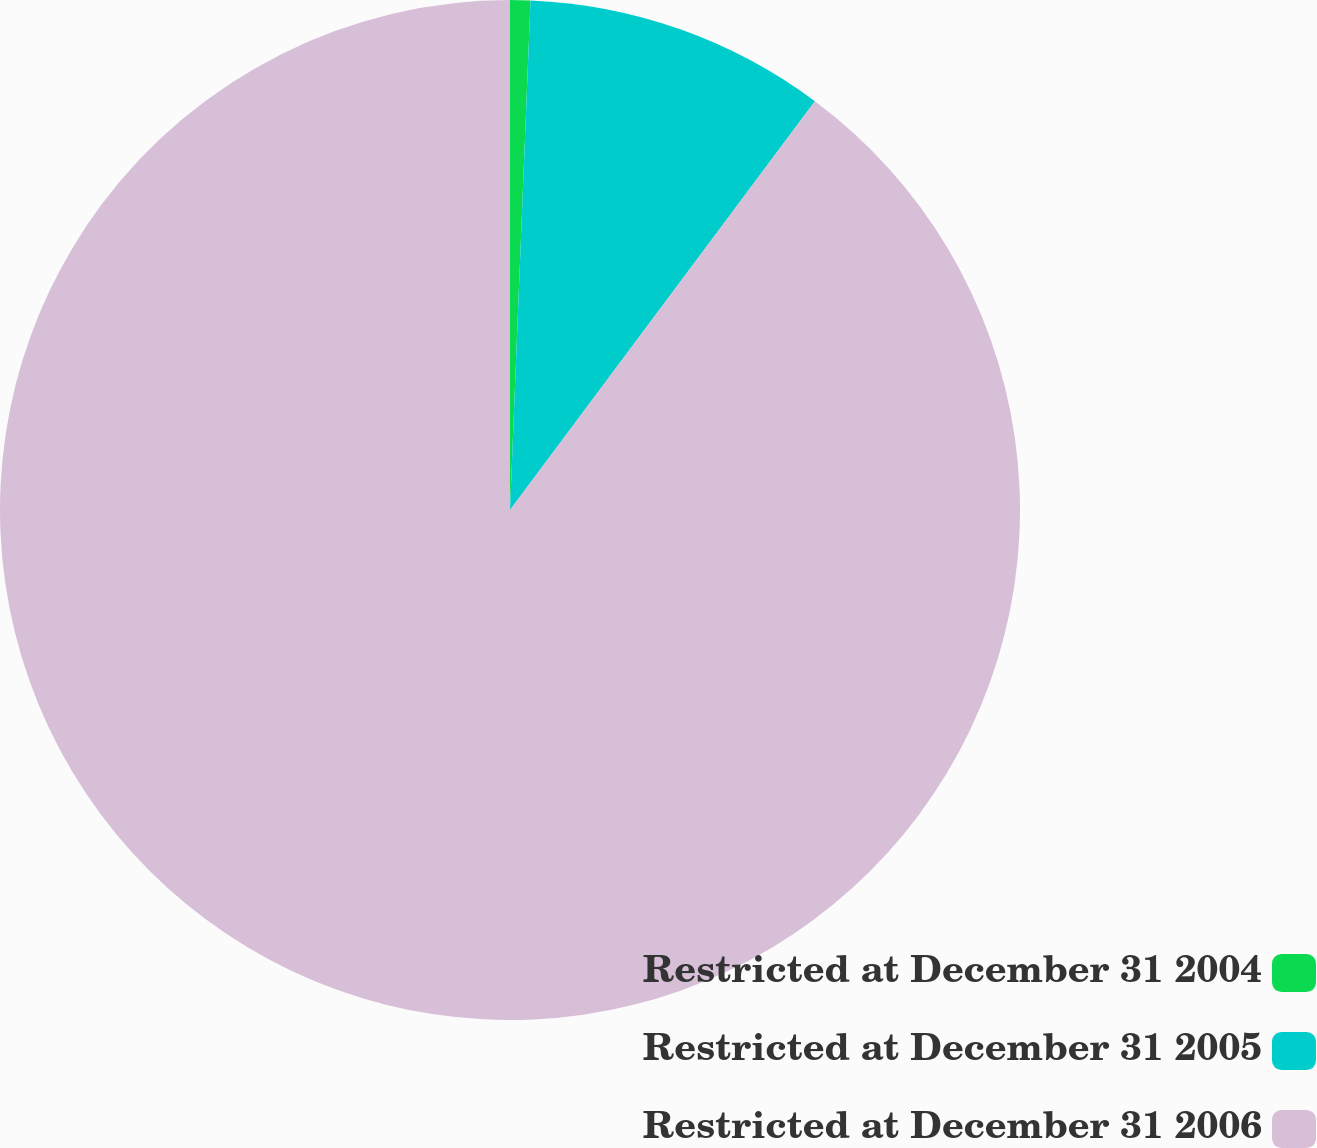Convert chart to OTSL. <chart><loc_0><loc_0><loc_500><loc_500><pie_chart><fcel>Restricted at December 31 2004<fcel>Restricted at December 31 2005<fcel>Restricted at December 31 2006<nl><fcel>0.64%<fcel>9.56%<fcel>89.81%<nl></chart> 